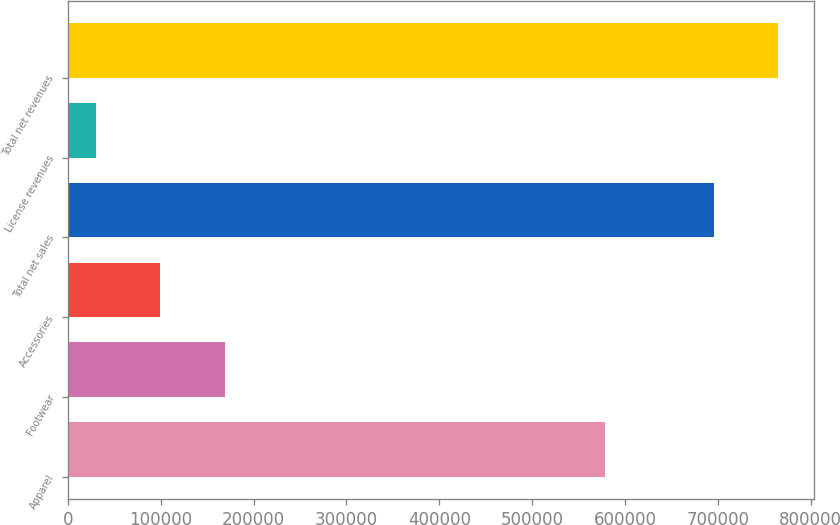<chart> <loc_0><loc_0><loc_500><loc_500><bar_chart><fcel>Apparel<fcel>Footwear<fcel>Accessories<fcel>Total net sales<fcel>License revenues<fcel>Total net revenues<nl><fcel>578887<fcel>169018<fcel>99490.2<fcel>695282<fcel>29962<fcel>764810<nl></chart> 